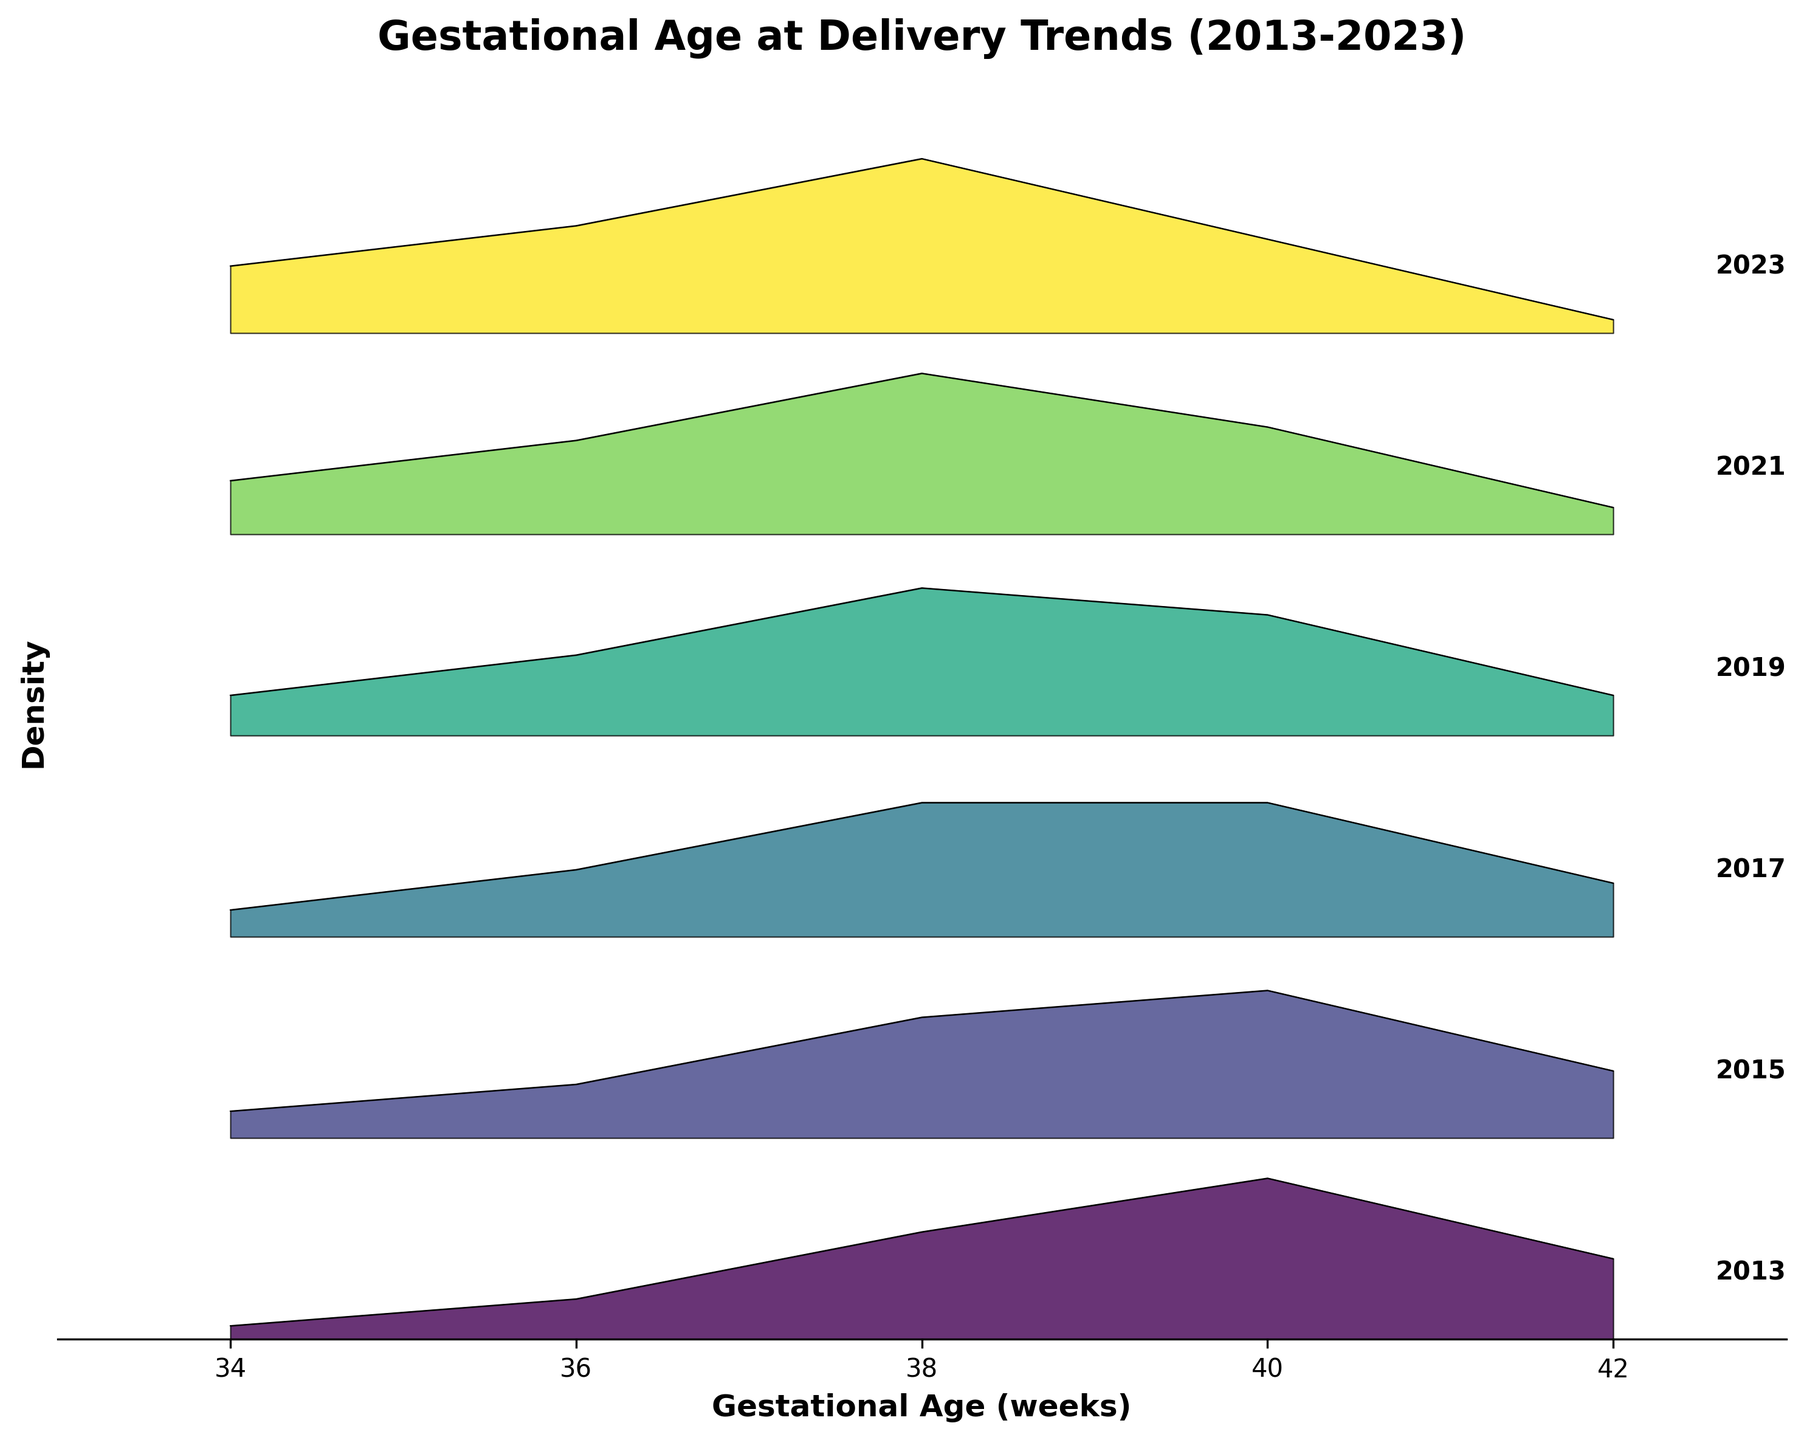what is the title of the plot? The plot title can be found at the top of the figure, which reads "Gestational Age at Delivery Trends (2013-2023)."
Answer: Gestational Age at Delivery Trends (2013-2023) What are the x-axis and y-axis labels? The x-axis is labeled 'Gestational Age (weeks)', and the y-axis is labeled 'Density'.
Answer: Gestational Age (weeks) and Density Which year shows the highest density at 34 weeks gestation? From inspecting the plot, the highest density at 34 weeks gestation is shown in 2023, where the density value is 0.05.
Answer: 2023 How has the density at 40 weeks gestation changed from 2013 to 2023? By comparing the density values at 40 weeks for 2013 (0.12) and 2023 (0.07), it has decreased over the years.
Answer: Decreased What trend can be observed in the density peak value of 38 weeks gestation from 2013 to 2023? From 2013 (0.08) to 2023 (0.13), there is a noticeable increase in the peak density value at 38 weeks over the years.
Answer: Increased What is the general trend in gestational age at delivery over the years? From the ridgeline plot, most densities shift towards higher values at 34, 36, and 38 weeks over time indicating a trend of earlier gestations becoming more common. Additionally, densities at 40 and 42 weeks decrease, implying fewer deliveries later.
Answer: Earlier gestations becoming more common Which year shows the lowest density at 42 weeks gestation? The year 2023 shows the lowest density at 42 weeks gestation with a value of 0.01.
Answer: 2023 What is the difference in density at 36 weeks gestation between 2015 and 2019? From the plot, the density at 36 weeks in 2015 is 0.04 and in 2019 is 0.06. The difference is 0.02.
Answer: 0.02 What can be inferred about trends at 38 weeks gestation from 2017 to 2019? Looking at the plot, the density at 38 weeks increased from 2017 (0.10) to 2019 (0.11), showing a slight but clear upward trend in this gestation period.
Answer: Slight upward trend How does the density at 40 weeks gestation in 2019 compare to that in 2013? The density at 40 weeks in 2019 is 0.09, while in 2013 it is 0.12. Thus, the density decreased from 2013 to 2019.
Answer: Decreased 